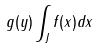<formula> <loc_0><loc_0><loc_500><loc_500>g ( y ) \int _ { J } f ( x ) d x</formula> 